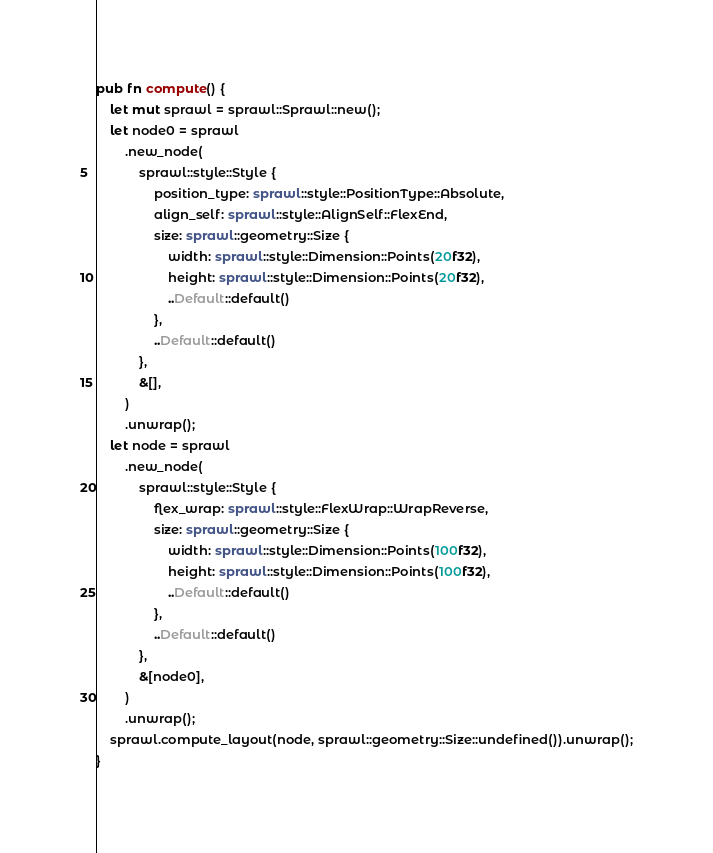Convert code to text. <code><loc_0><loc_0><loc_500><loc_500><_Rust_>pub fn compute() {
    let mut sprawl = sprawl::Sprawl::new();
    let node0 = sprawl
        .new_node(
            sprawl::style::Style {
                position_type: sprawl::style::PositionType::Absolute,
                align_self: sprawl::style::AlignSelf::FlexEnd,
                size: sprawl::geometry::Size {
                    width: sprawl::style::Dimension::Points(20f32),
                    height: sprawl::style::Dimension::Points(20f32),
                    ..Default::default()
                },
                ..Default::default()
            },
            &[],
        )
        .unwrap();
    let node = sprawl
        .new_node(
            sprawl::style::Style {
                flex_wrap: sprawl::style::FlexWrap::WrapReverse,
                size: sprawl::geometry::Size {
                    width: sprawl::style::Dimension::Points(100f32),
                    height: sprawl::style::Dimension::Points(100f32),
                    ..Default::default()
                },
                ..Default::default()
            },
            &[node0],
        )
        .unwrap();
    sprawl.compute_layout(node, sprawl::geometry::Size::undefined()).unwrap();
}
</code> 